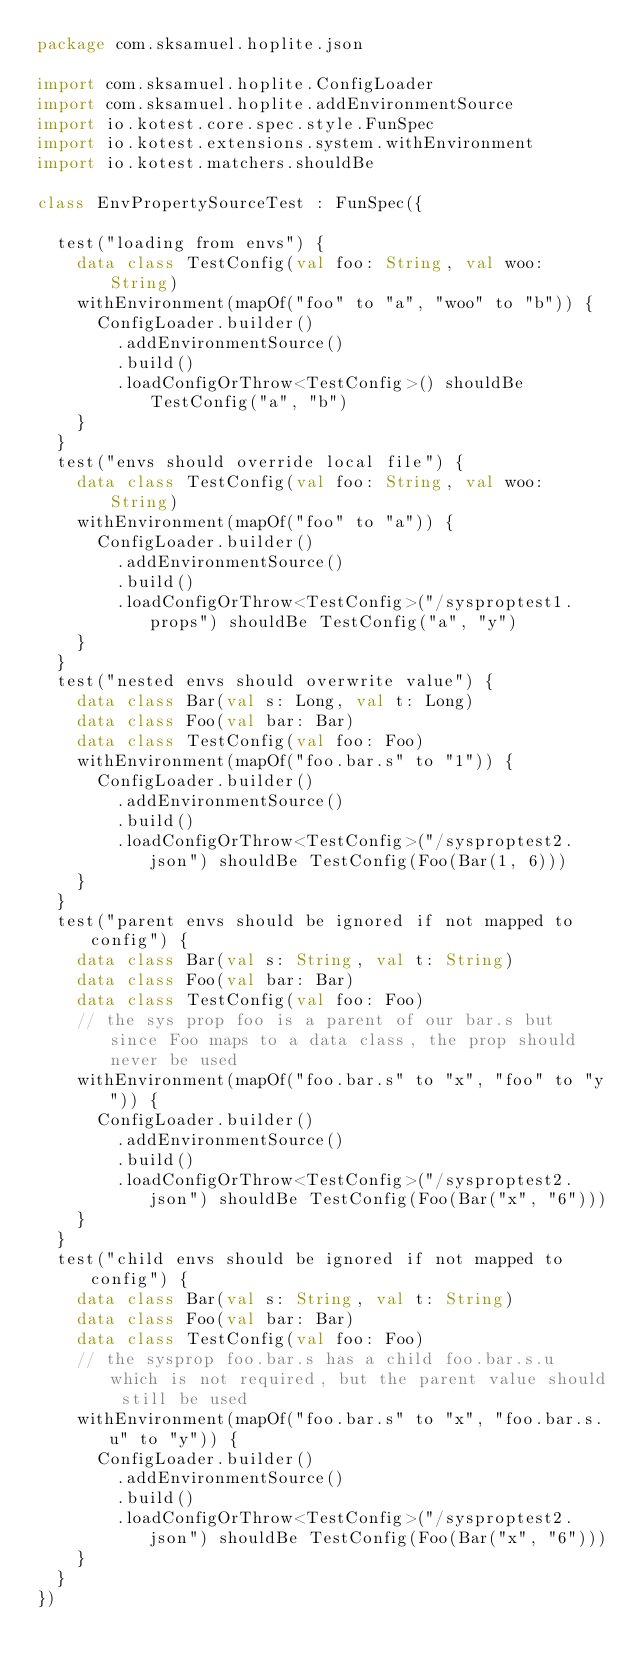<code> <loc_0><loc_0><loc_500><loc_500><_Kotlin_>package com.sksamuel.hoplite.json

import com.sksamuel.hoplite.ConfigLoader
import com.sksamuel.hoplite.addEnvironmentSource
import io.kotest.core.spec.style.FunSpec
import io.kotest.extensions.system.withEnvironment
import io.kotest.matchers.shouldBe

class EnvPropertySourceTest : FunSpec({

  test("loading from envs") {
    data class TestConfig(val foo: String, val woo: String)
    withEnvironment(mapOf("foo" to "a", "woo" to "b")) {
      ConfigLoader.builder()
        .addEnvironmentSource()
        .build()
        .loadConfigOrThrow<TestConfig>() shouldBe TestConfig("a", "b")
    }
  }
  test("envs should override local file") {
    data class TestConfig(val foo: String, val woo: String)
    withEnvironment(mapOf("foo" to "a")) {
      ConfigLoader.builder()
        .addEnvironmentSource()
        .build()
        .loadConfigOrThrow<TestConfig>("/sysproptest1.props") shouldBe TestConfig("a", "y")
    }
  }
  test("nested envs should overwrite value") {
    data class Bar(val s: Long, val t: Long)
    data class Foo(val bar: Bar)
    data class TestConfig(val foo: Foo)
    withEnvironment(mapOf("foo.bar.s" to "1")) {
      ConfigLoader.builder()
        .addEnvironmentSource()
        .build()
        .loadConfigOrThrow<TestConfig>("/sysproptest2.json") shouldBe TestConfig(Foo(Bar(1, 6)))
    }
  }
  test("parent envs should be ignored if not mapped to config") {
    data class Bar(val s: String, val t: String)
    data class Foo(val bar: Bar)
    data class TestConfig(val foo: Foo)
    // the sys prop foo is a parent of our bar.s but since Foo maps to a data class, the prop should never be used
    withEnvironment(mapOf("foo.bar.s" to "x", "foo" to "y")) {
      ConfigLoader.builder()
        .addEnvironmentSource()
        .build()
        .loadConfigOrThrow<TestConfig>("/sysproptest2.json") shouldBe TestConfig(Foo(Bar("x", "6")))
    }
  }
  test("child envs should be ignored if not mapped to config") {
    data class Bar(val s: String, val t: String)
    data class Foo(val bar: Bar)
    data class TestConfig(val foo: Foo)
    // the sysprop foo.bar.s has a child foo.bar.s.u which is not required, but the parent value should still be used
    withEnvironment(mapOf("foo.bar.s" to "x", "foo.bar.s.u" to "y")) {
      ConfigLoader.builder()
        .addEnvironmentSource()
        .build()
        .loadConfigOrThrow<TestConfig>("/sysproptest2.json") shouldBe TestConfig(Foo(Bar("x", "6")))
    }
  }
})
</code> 